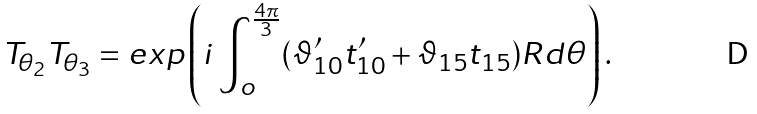Convert formula to latex. <formula><loc_0><loc_0><loc_500><loc_500>T _ { \theta _ { 2 } } T _ { \theta _ { 3 } } = e x p \left ( i \int _ { o } ^ { \frac { 4 \pi } { 3 } } ( \vartheta ^ { \prime } _ { 1 0 } t ^ { \prime } _ { 1 0 } + \vartheta _ { 1 5 } t _ { 1 5 } ) R d \theta \right ) .</formula> 